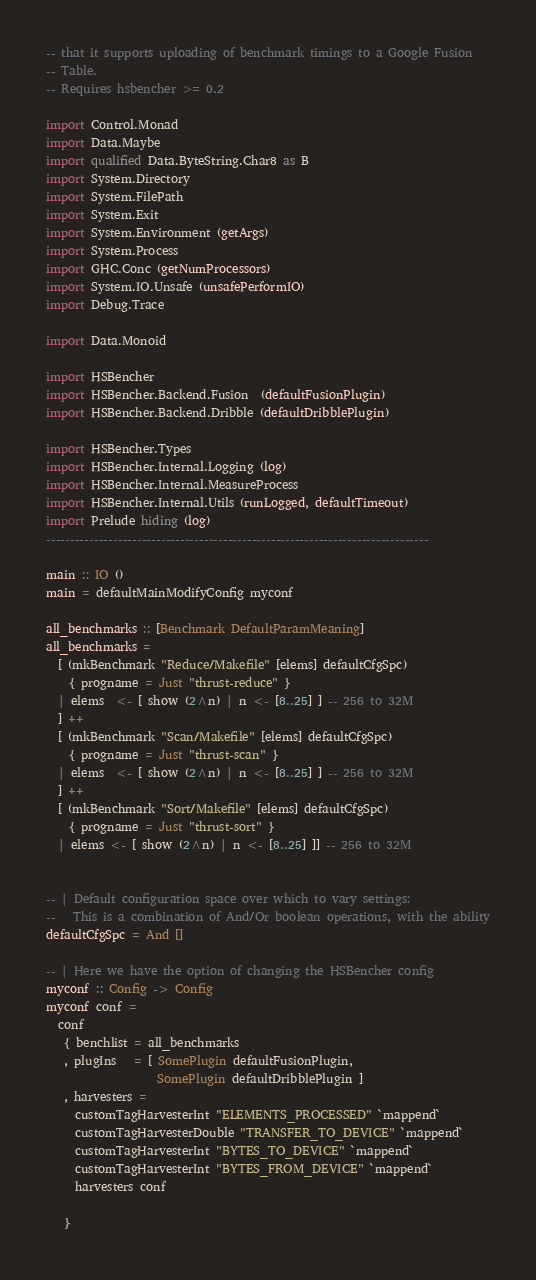Convert code to text. <code><loc_0><loc_0><loc_500><loc_500><_Haskell_>-- that it supports uploading of benchmark timings to a Google Fusion
-- Table.
-- Requires hsbencher >= 0.2

import Control.Monad
import Data.Maybe
import qualified Data.ByteString.Char8 as B
import System.Directory
import System.FilePath
import System.Exit
import System.Environment (getArgs)
import System.Process
import GHC.Conc (getNumProcessors)
import System.IO.Unsafe (unsafePerformIO)
import Debug.Trace

import Data.Monoid

import HSBencher 
import HSBencher.Backend.Fusion  (defaultFusionPlugin)
import HSBencher.Backend.Dribble (defaultDribblePlugin)

import HSBencher.Types
import HSBencher.Internal.Logging (log)
import HSBencher.Internal.MeasureProcess
import HSBencher.Internal.Utils (runLogged, defaultTimeout)
import Prelude hiding (log)
--------------------------------------------------------------------------------

main :: IO ()
main = defaultMainModifyConfig myconf

all_benchmarks :: [Benchmark DefaultParamMeaning]
all_benchmarks =
  [ (mkBenchmark "Reduce/Makefile" [elems] defaultCfgSpc)
    { progname = Just "thrust-reduce" } 
  | elems  <- [ show (2^n) | n <- [8..25] ] -- 256 to 32M
  ] ++ 
  [ (mkBenchmark "Scan/Makefile" [elems] defaultCfgSpc)
    { progname = Just "thrust-scan" } 
  | elems  <- [ show (2^n) | n <- [8..25] ] -- 256 to 32M
  ] ++
  [ (mkBenchmark "Sort/Makefile" [elems] defaultCfgSpc)
    { progname = Just "thrust-sort" }
  | elems <- [ show (2^n) | n <- [8..25] ]] -- 256 to 32M

  
-- | Default configuration space over which to vary settings:
--   This is a combination of And/Or boolean operations, with the ability
defaultCfgSpc = And []

-- | Here we have the option of changing the HSBencher config
myconf :: Config -> Config
myconf conf =
  conf
   { benchlist = all_benchmarks
   , plugIns   = [ SomePlugin defaultFusionPlugin,
                   SomePlugin defaultDribblePlugin ]
   , harvesters =
     customTagHarvesterInt "ELEMENTS_PROCESSED" `mappend`
     customTagHarvesterDouble "TRANSFER_TO_DEVICE" `mappend`
     customTagHarvesterInt "BYTES_TO_DEVICE" `mappend`
     customTagHarvesterInt "BYTES_FROM_DEVICE" `mappend`
     harvesters conf

   }

</code> 